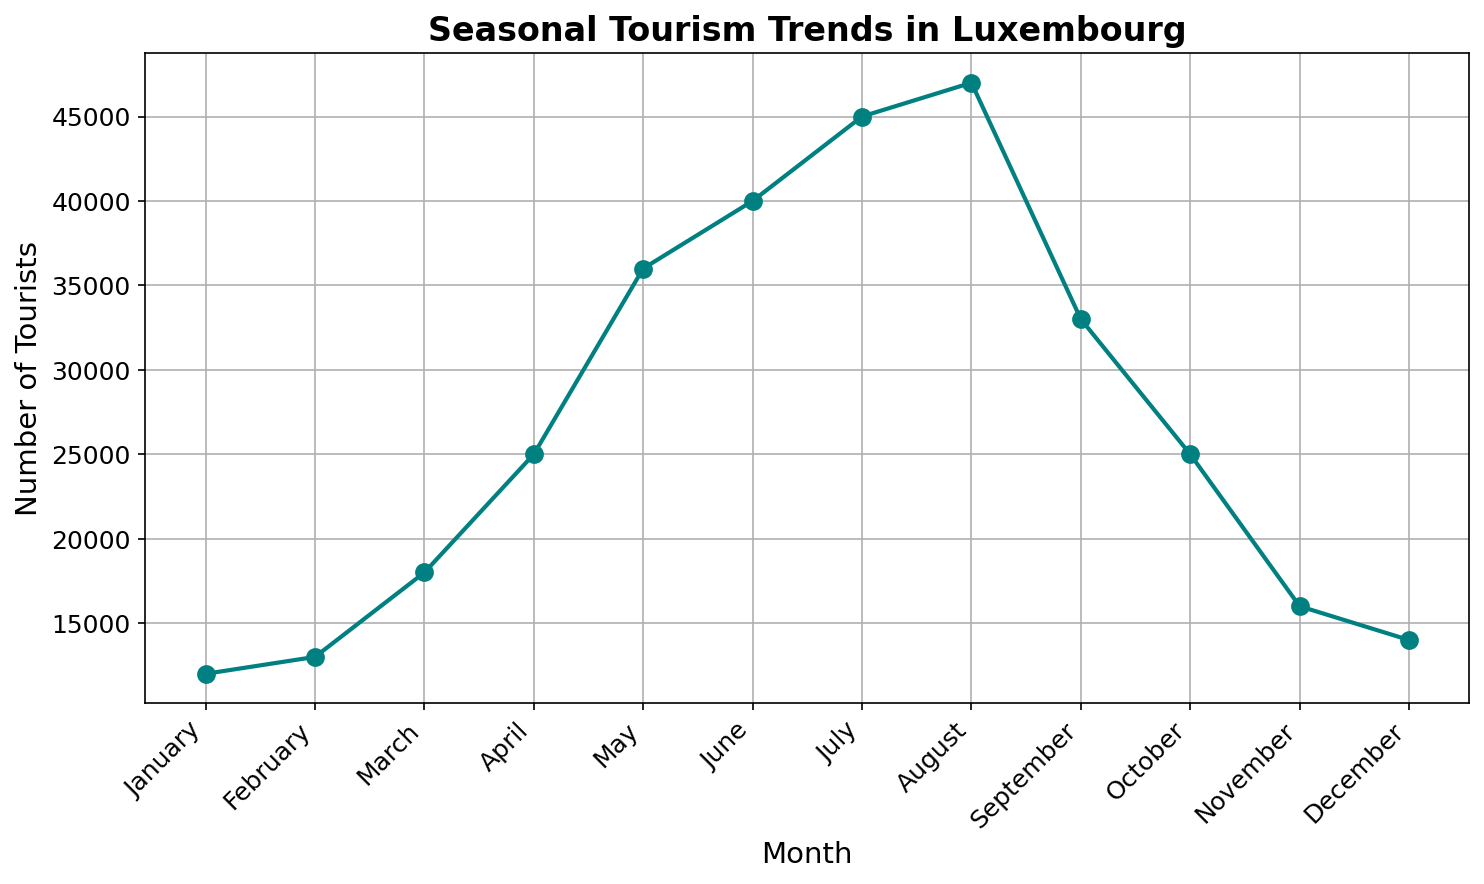What's the trend in the number of tourists from January to December? From January to December, the number of tourists rises steadily, reaching a peak in August at 47,000, and then declines towards December.
Answer: Rising to August, then falling In which month did Luxembourg experience the highest number of tourists? Observing the peak of the line on the chart, August saw the highest number of tourists, totaling 47,000.
Answer: August Compare the number of tourists in March and November. Which month had more tourists and by how much? March had 18,000 tourists, while November had 16,000. Subtracting 16,000 from 18,000, March had 2,000 more tourists than November.
Answer: March, 2,000 more What is the average number of tourists from January to June? Adding the tourists from January (12,000), February (13,000), March (18,000), April (25,000), May (36,000), and June (40,000), we get the total of 144,000. Dividing by 6, the average is 24,000.
Answer: 24,000 Between which two consecutive months is the increase in tourists the greatest? The increase between April (25,000) and May (36,000) is 11,000, which is the greatest rise when compared to other consecutive months.
Answer: April and May How does the number of tourists in December compare to the number of tourists in February? December has 14,000 tourists, which is 1,000 more than February's 13,000 tourists.
Answer: December, 1,000 more Which months have a number of tourists greater than the average from January to December? The average number of tourists is calculated as: (12,000 + 13,000 + 18,000 + 25,000 + 36,000 + 40,000 + 45,000 + 47,000 + 33,000 + 25,000 + 16,000 + 14,000)/12 = 26,750. The months with greater than 26,750 tourists are May, June, July, August, and September.
Answer: May, June, July, August, September What is the total number of tourists in the peak summer months (June, July, August)? Adding the number of tourists for June (40,000), July (45,000), and August (47,000), the total is 132,000.
Answer: 132,000 Describe the visual style used in the plot and its impact on readability. The line is marked with circles and a teal color, enhanced by labels and gridlines, creating clear and visually distinguishable trend patterns. This styling aids in easily reading and interpreting the data.
Answer: Clear and readable 